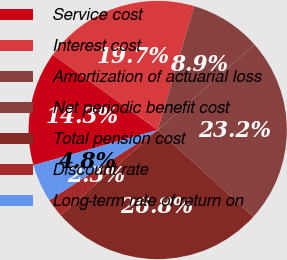Convert chart. <chart><loc_0><loc_0><loc_500><loc_500><pie_chart><fcel>Service cost<fcel>Interest cost<fcel>Amortization of actuarial loss<fcel>Net periodic benefit cost<fcel>Total pension cost<fcel>Discount rate<fcel>Long-term rate of return on<nl><fcel>14.3%<fcel>19.66%<fcel>8.93%<fcel>23.23%<fcel>26.8%<fcel>2.31%<fcel>4.76%<nl></chart> 